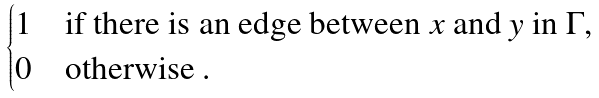<formula> <loc_0><loc_0><loc_500><loc_500>\begin{cases} 1 & \text {if there is an edge between $x$ and $y$ in $\Gamma$,} \\ 0 & \text {otherwise .} \end{cases}</formula> 